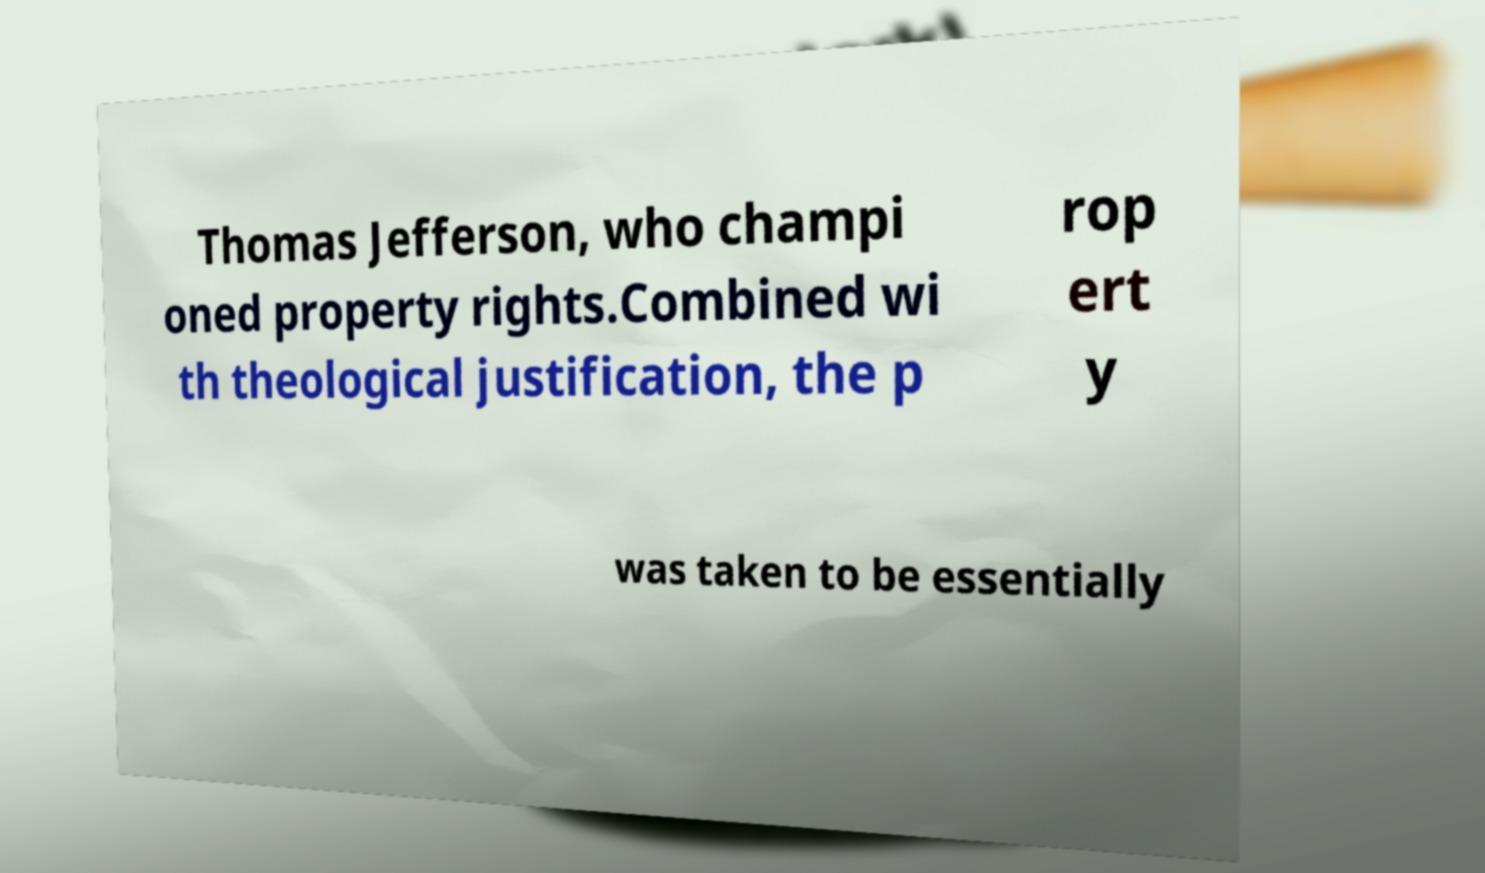Can you read and provide the text displayed in the image?This photo seems to have some interesting text. Can you extract and type it out for me? Thomas Jefferson, who champi oned property rights.Combined wi th theological justification, the p rop ert y was taken to be essentially 